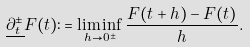Convert formula to latex. <formula><loc_0><loc_0><loc_500><loc_500>\underline { \partial _ { t } ^ { \pm } } F ( t ) \colon = \liminf _ { h \to 0 ^ { \pm } } \frac { F ( t + h ) - F ( t ) } { h } .</formula> 